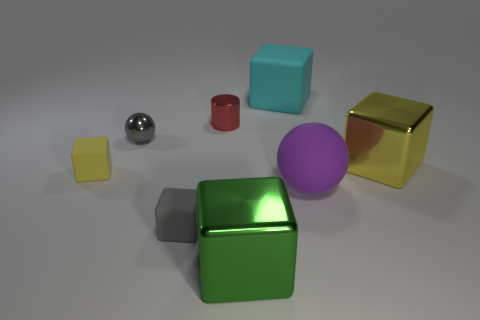What is the material of the purple object that is the same size as the green metallic thing? The purple object appears to be made of a matte plastic material, as indicated by its lack of reflective properties compared to the shiny metallic surface of the green item. 